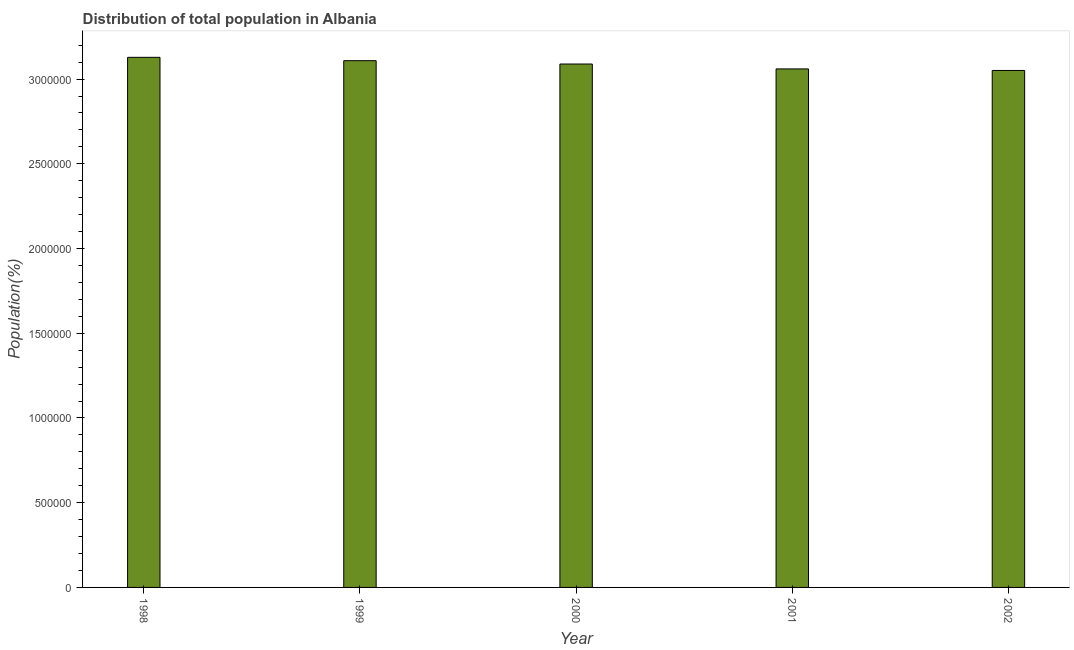Does the graph contain any zero values?
Provide a succinct answer. No. What is the title of the graph?
Your response must be concise. Distribution of total population in Albania . What is the label or title of the Y-axis?
Make the answer very short. Population(%). What is the population in 2002?
Make the answer very short. 3.05e+06. Across all years, what is the maximum population?
Keep it short and to the point. 3.13e+06. Across all years, what is the minimum population?
Ensure brevity in your answer.  3.05e+06. In which year was the population maximum?
Your response must be concise. 1998. In which year was the population minimum?
Your response must be concise. 2002. What is the sum of the population?
Keep it short and to the point. 1.54e+07. What is the difference between the population in 2000 and 2001?
Your response must be concise. 2.89e+04. What is the average population per year?
Offer a terse response. 3.09e+06. What is the median population?
Provide a succinct answer. 3.09e+06. In how many years, is the population greater than 900000 %?
Provide a succinct answer. 5. Is the difference between the population in 1998 and 2000 greater than the difference between any two years?
Provide a succinct answer. No. What is the difference between the highest and the second highest population?
Provide a succinct answer. 1.98e+04. What is the difference between the highest and the lowest population?
Your answer should be very brief. 7.75e+04. Are all the bars in the graph horizontal?
Provide a short and direct response. No. How many years are there in the graph?
Provide a succinct answer. 5. Are the values on the major ticks of Y-axis written in scientific E-notation?
Offer a terse response. No. What is the Population(%) of 1998?
Give a very brief answer. 3.13e+06. What is the Population(%) of 1999?
Make the answer very short. 3.11e+06. What is the Population(%) of 2000?
Provide a succinct answer. 3.09e+06. What is the Population(%) in 2001?
Provide a succinct answer. 3.06e+06. What is the Population(%) of 2002?
Give a very brief answer. 3.05e+06. What is the difference between the Population(%) in 1998 and 1999?
Provide a short and direct response. 1.98e+04. What is the difference between the Population(%) in 1998 and 2000?
Ensure brevity in your answer.  3.95e+04. What is the difference between the Population(%) in 1998 and 2001?
Offer a terse response. 6.84e+04. What is the difference between the Population(%) in 1998 and 2002?
Your answer should be compact. 7.75e+04. What is the difference between the Population(%) in 1999 and 2000?
Offer a terse response. 1.98e+04. What is the difference between the Population(%) in 1999 and 2001?
Your answer should be compact. 4.86e+04. What is the difference between the Population(%) in 1999 and 2002?
Provide a short and direct response. 5.78e+04. What is the difference between the Population(%) in 2000 and 2001?
Your response must be concise. 2.89e+04. What is the difference between the Population(%) in 2000 and 2002?
Provide a succinct answer. 3.80e+04. What is the difference between the Population(%) in 2001 and 2002?
Your answer should be very brief. 9163. What is the ratio of the Population(%) in 1998 to that in 1999?
Ensure brevity in your answer.  1.01. What is the ratio of the Population(%) in 1998 to that in 2000?
Offer a terse response. 1.01. 